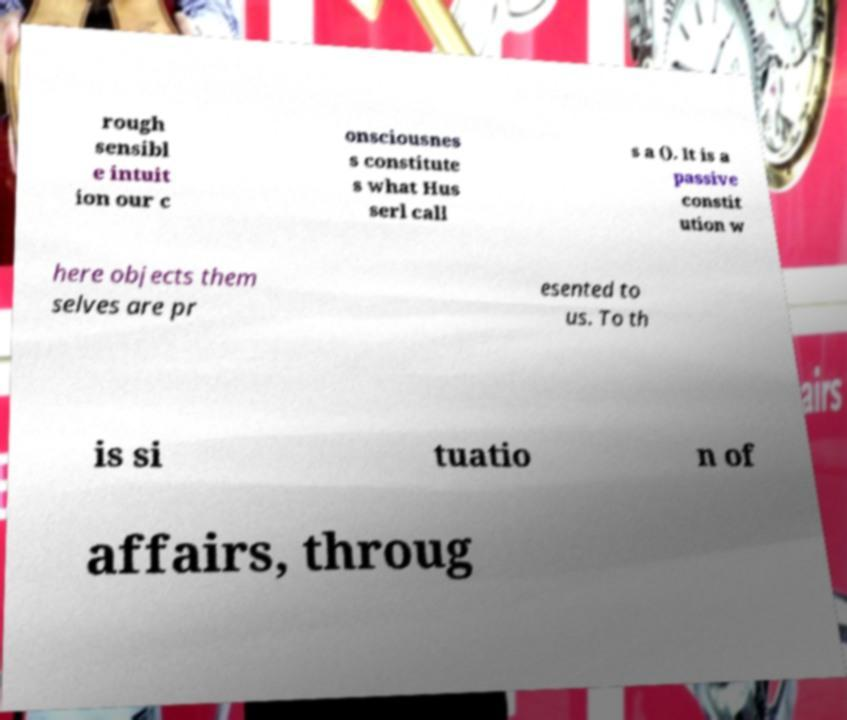Could you extract and type out the text from this image? rough sensibl e intuit ion our c onsciousnes s constitute s what Hus serl call s a (). It is a passive constit ution w here objects them selves are pr esented to us. To th is si tuatio n of affairs, throug 